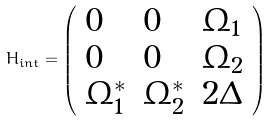Convert formula to latex. <formula><loc_0><loc_0><loc_500><loc_500>H _ { i n t } = \left ( \begin{array} { l l l } 0 & 0 & \Omega _ { 1 } \\ 0 & 0 & \Omega _ { 2 } \\ \Omega _ { 1 } ^ { \ast } & \Omega _ { 2 } ^ { \ast } & 2 \Delta \end{array} \right )</formula> 